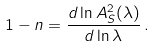Convert formula to latex. <formula><loc_0><loc_0><loc_500><loc_500>1 - n = \frac { d \ln A _ { S } ^ { 2 } ( \lambda ) } { d \ln \lambda } \, .</formula> 